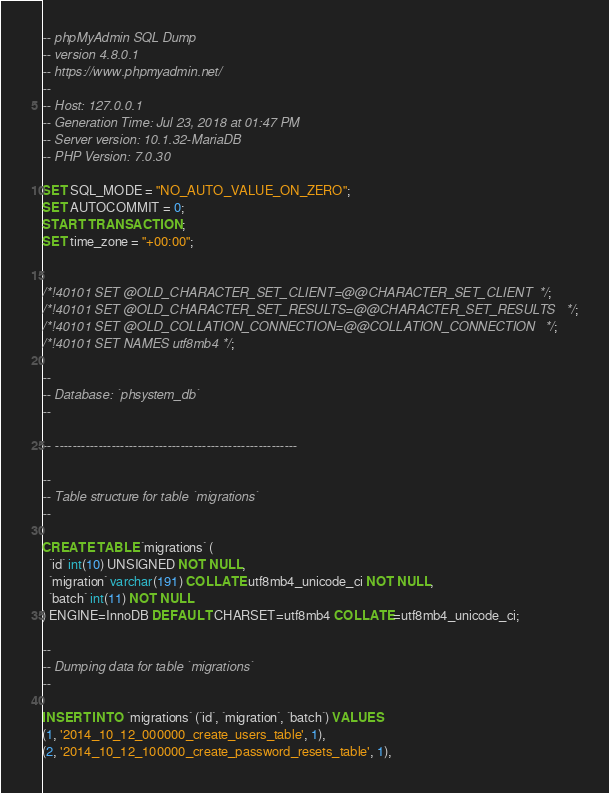Convert code to text. <code><loc_0><loc_0><loc_500><loc_500><_SQL_>-- phpMyAdmin SQL Dump
-- version 4.8.0.1
-- https://www.phpmyadmin.net/
--
-- Host: 127.0.0.1
-- Generation Time: Jul 23, 2018 at 01:47 PM
-- Server version: 10.1.32-MariaDB
-- PHP Version: 7.0.30

SET SQL_MODE = "NO_AUTO_VALUE_ON_ZERO";
SET AUTOCOMMIT = 0;
START TRANSACTION;
SET time_zone = "+00:00";


/*!40101 SET @OLD_CHARACTER_SET_CLIENT=@@CHARACTER_SET_CLIENT */;
/*!40101 SET @OLD_CHARACTER_SET_RESULTS=@@CHARACTER_SET_RESULTS */;
/*!40101 SET @OLD_COLLATION_CONNECTION=@@COLLATION_CONNECTION */;
/*!40101 SET NAMES utf8mb4 */;

--
-- Database: `phsystem_db`
--

-- --------------------------------------------------------

--
-- Table structure for table `migrations`
--

CREATE TABLE `migrations` (
  `id` int(10) UNSIGNED NOT NULL,
  `migration` varchar(191) COLLATE utf8mb4_unicode_ci NOT NULL,
  `batch` int(11) NOT NULL
) ENGINE=InnoDB DEFAULT CHARSET=utf8mb4 COLLATE=utf8mb4_unicode_ci;

--
-- Dumping data for table `migrations`
--

INSERT INTO `migrations` (`id`, `migration`, `batch`) VALUES
(1, '2014_10_12_000000_create_users_table', 1),
(2, '2014_10_12_100000_create_password_resets_table', 1),</code> 